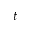Convert formula to latex. <formula><loc_0><loc_0><loc_500><loc_500>t</formula> 